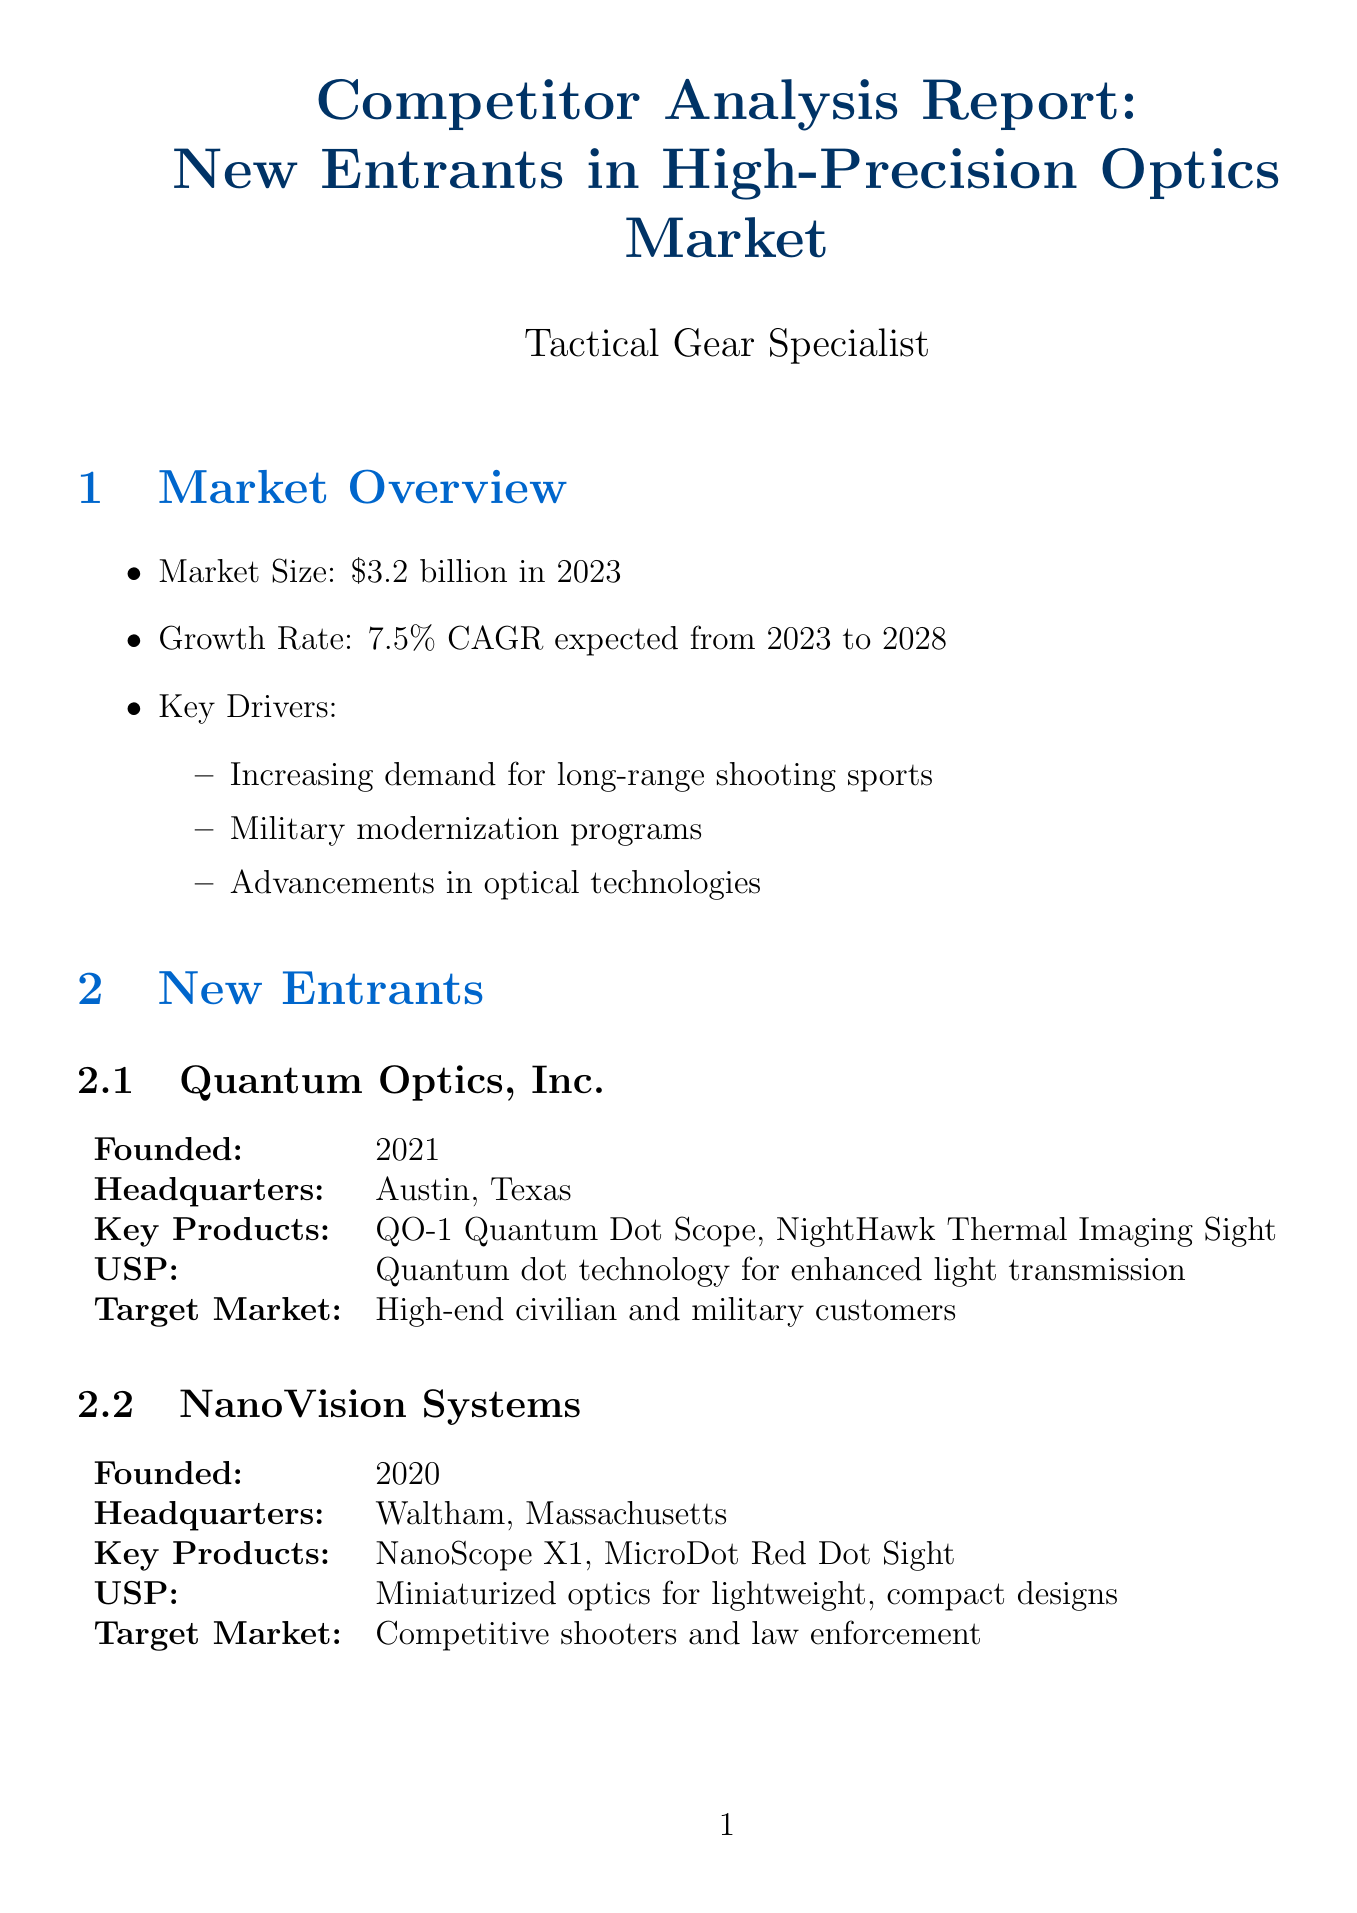What is the market size in 2023? The market size is specified in the market overview section, which states it is $3.2 billion in 2023.
Answer: $3.2 billion Who founded Quantum Optics, Inc.? The founded date of Quantum Optics, Inc. is provided in the new entrants section, indicating it was founded in 2021.
Answer: 2021 What unique selling point does NanoVision Systems emphasize? The document mentions that NanoVision Systems focuses on miniaturized optics for lightweight, compact designs as its unique selling point.
Answer: Miniaturized optics for lightweight, compact designs What distribution channels does Alpine Precision Optics utilize? The distribution channels of Alpine Precision Optics are listed in the competitive analysis section, showing they use outdoor gear retailers and online direct sales.
Answer: Outdoor gear retailers, Online direct sales What is the expected growth rate of the market from 2023 to 2028? The growth rate is described in the market overview, where it states a 7.5% CAGR expected from 2023 to 2028.
Answer: 7.5% CAGR What potential impact does the report suggest may occur in the short term? The document outlines several short-term impacts, one of which includes increased price competition in the premium segment.
Answer: Increased price competition in premium segment Which company focuses on extreme weather performance? The document specifies Alpine Precision Optics as the company that emphasizes extreme weather performance for mountainous environments.
Answer: Alpine Precision Optics What recommendation suggests enhancing online capabilities? In the recommendations section, it states to enhance online presence and e-commerce capabilities to compete with models.
Answer: Enhance online presence and e-commerce capabilities 